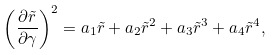Convert formula to latex. <formula><loc_0><loc_0><loc_500><loc_500>\left ( \frac { \partial \tilde { r } } { \partial \gamma } \right ) ^ { 2 } = a _ { 1 } \tilde { r } + a _ { 2 } \tilde { r } ^ { 2 } + a _ { 3 } \tilde { r } ^ { 3 } + a _ { 4 } \tilde { r } ^ { 4 } ,</formula> 